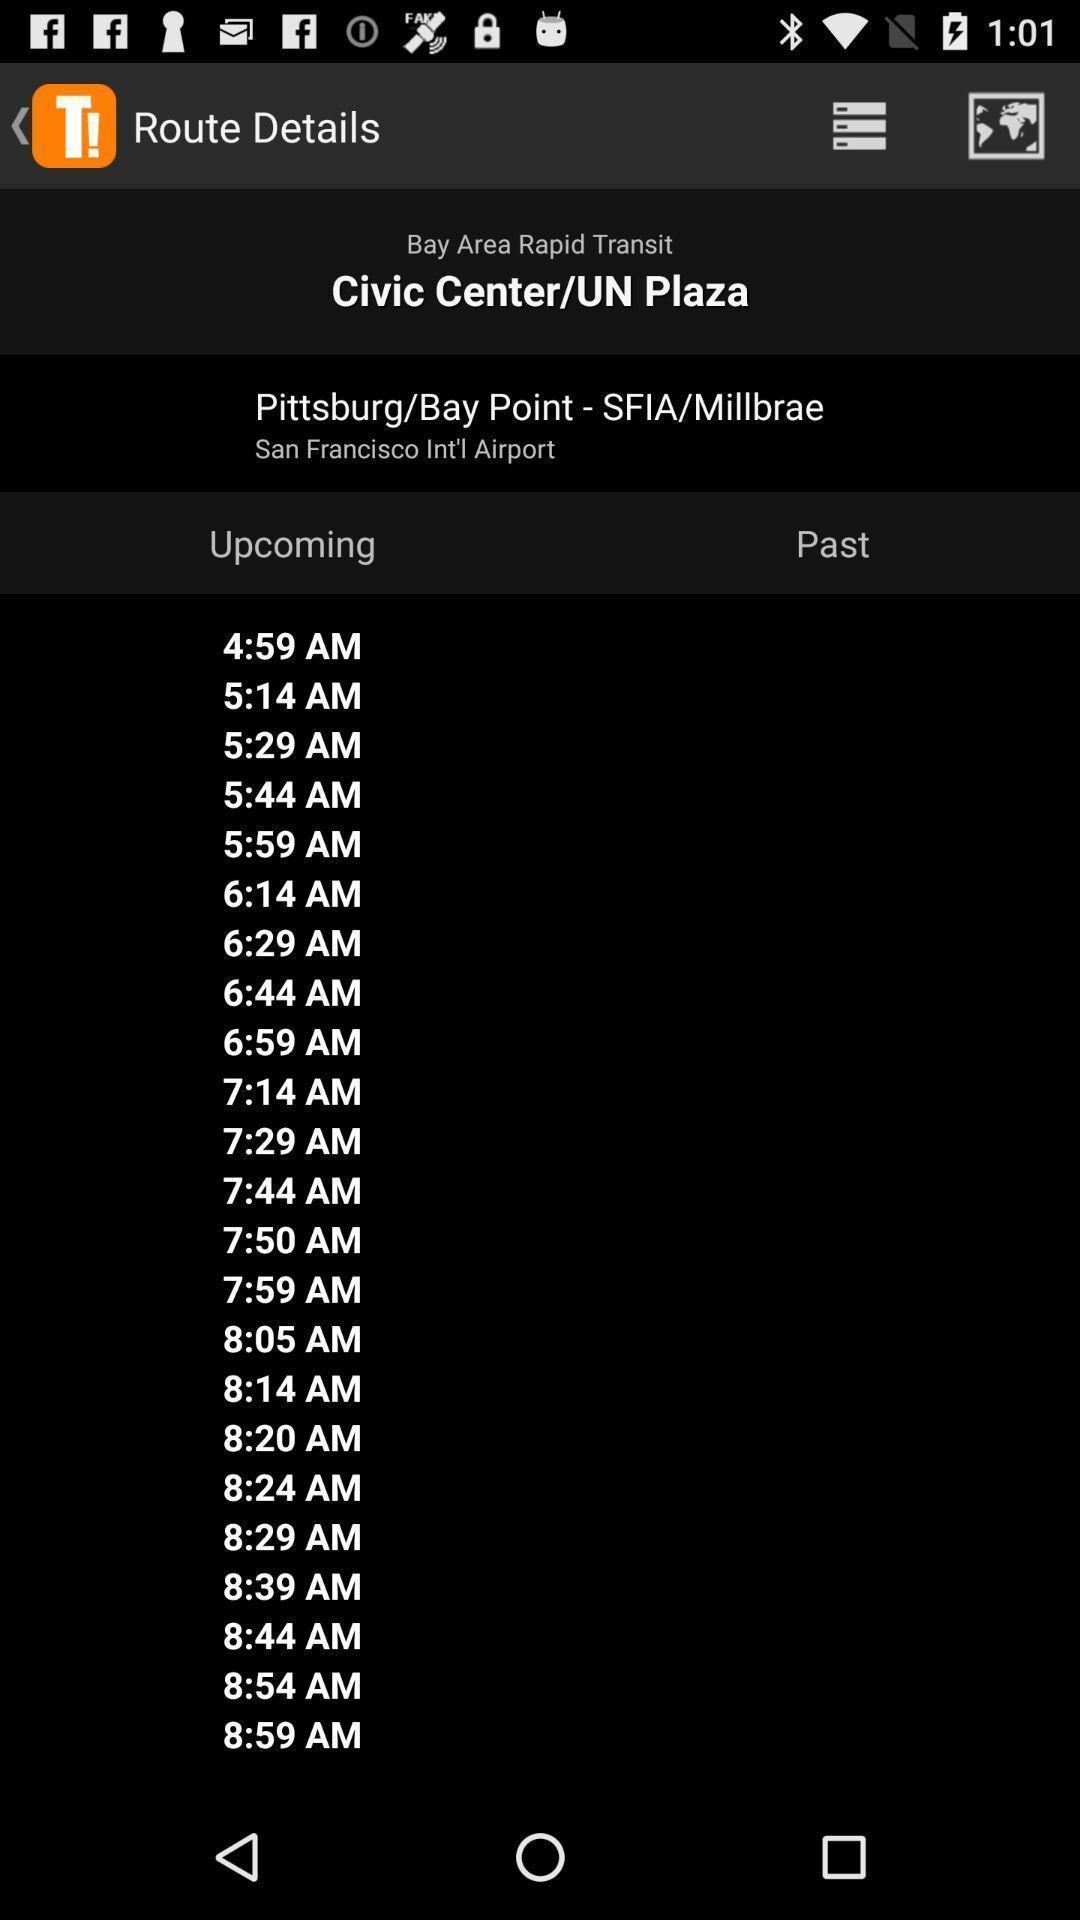Summarize the main components in this picture. Page displaying route details of a public transportation app. 